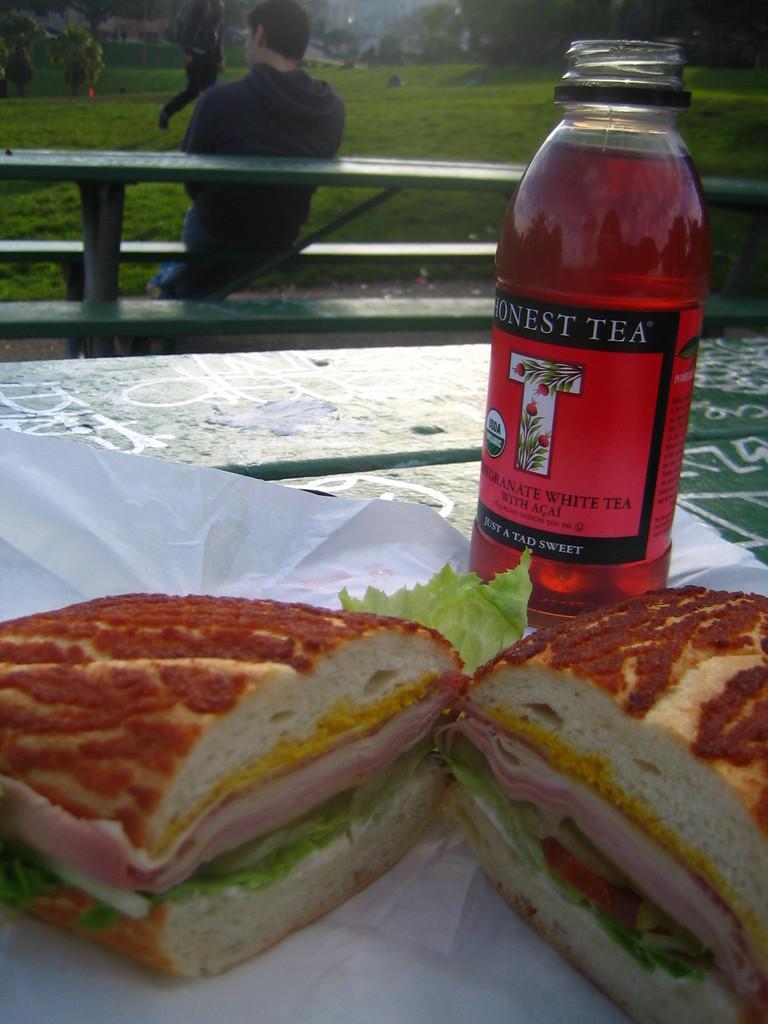In one or two sentences, can you explain what this image depicts? in the picture we can see the food items placed on the table along with the bottle and we can see a person sitting on the bench a bit away from the table and we can see grass and we can see the person walking on the grass. 